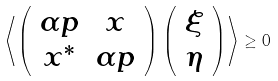<formula> <loc_0><loc_0><loc_500><loc_500>\left \langle \left ( \begin{array} { c c } \alpha p & x \\ x ^ { * } & \alpha p \end{array} \right ) \left ( \begin{array} { c } \xi \\ \eta \end{array} \right ) \right \rangle \geq 0</formula> 